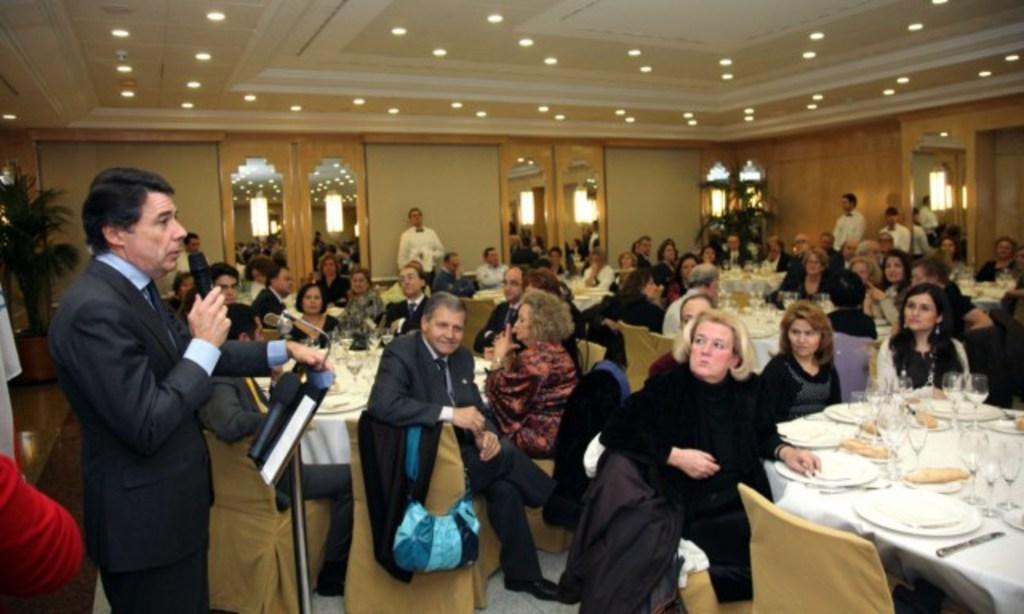Could you give a brief overview of what you see in this image? There are group of people sitting on the chairs. There are Three tables covered with white cloth. These are the plates,wine glasses and few other things placed on the table. Here is the man standing,holding mike and talking. These are the doors. These are the ceiling lights attached to the rooftop. This looks like a houseplant. 